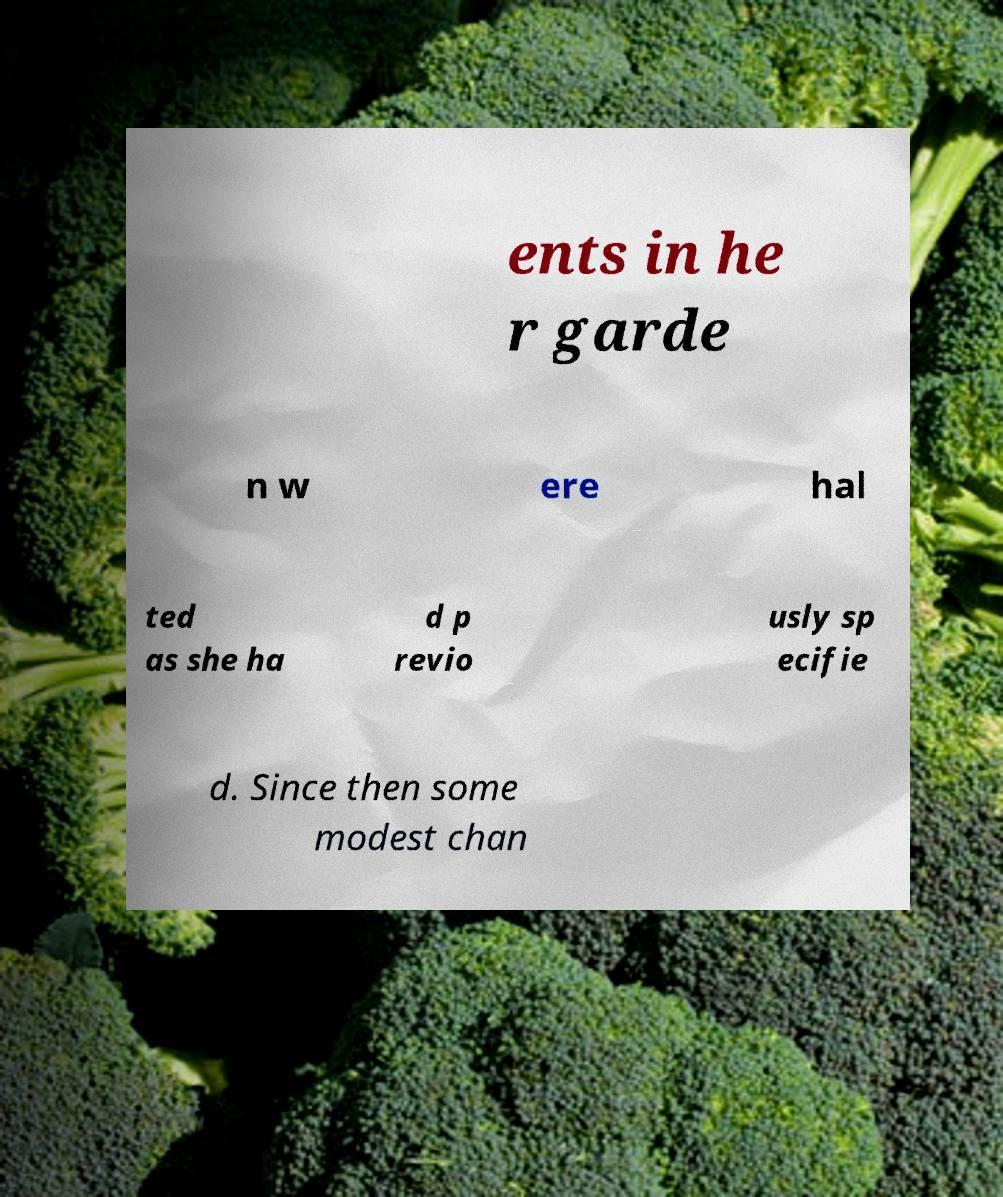Can you read and provide the text displayed in the image?This photo seems to have some interesting text. Can you extract and type it out for me? ents in he r garde n w ere hal ted as she ha d p revio usly sp ecifie d. Since then some modest chan 